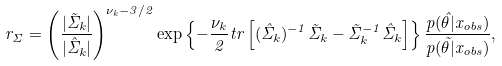<formula> <loc_0><loc_0><loc_500><loc_500>r _ { \Sigma } = \left ( \frac { | \tilde { \Sigma } _ { k } | } { | \hat { \Sigma } _ { k } | } \right ) ^ { \nu _ { k } - 3 / 2 } \exp \left \{ - \frac { \nu _ { k } } { 2 } t r \left [ ( \hat { \Sigma } _ { k } ) ^ { - 1 } \tilde { \Sigma } _ { k } - \tilde { \Sigma } _ { k } ^ { - 1 } \hat { \Sigma } _ { k } \right ] \right \} \frac { p ( \hat { \theta } | x _ { o b s } ) } { p ( \tilde { \theta } | x _ { o b s } ) } ,</formula> 